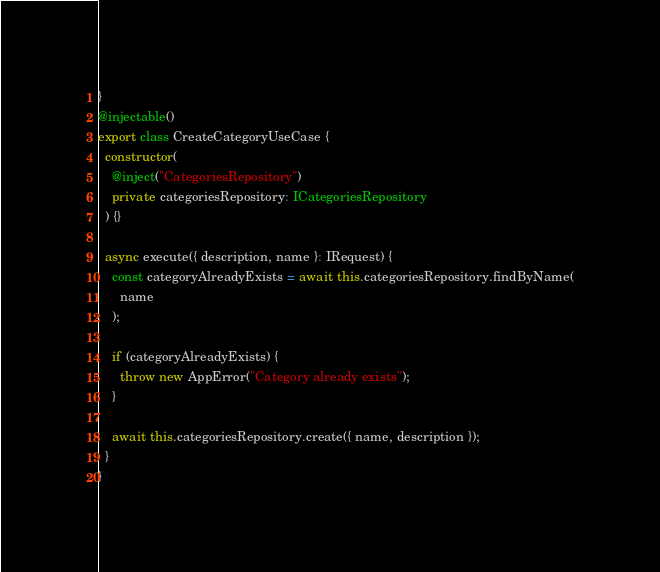Convert code to text. <code><loc_0><loc_0><loc_500><loc_500><_TypeScript_>}
@injectable()
export class CreateCategoryUseCase {
  constructor(
    @inject("CategoriesRepository")
    private categoriesRepository: ICategoriesRepository
  ) {}

  async execute({ description, name }: IRequest) {
    const categoryAlreadyExists = await this.categoriesRepository.findByName(
      name
    );

    if (categoryAlreadyExists) {
      throw new AppError("Category already exists");
    }

    await this.categoriesRepository.create({ name, description });
  }
}
</code> 